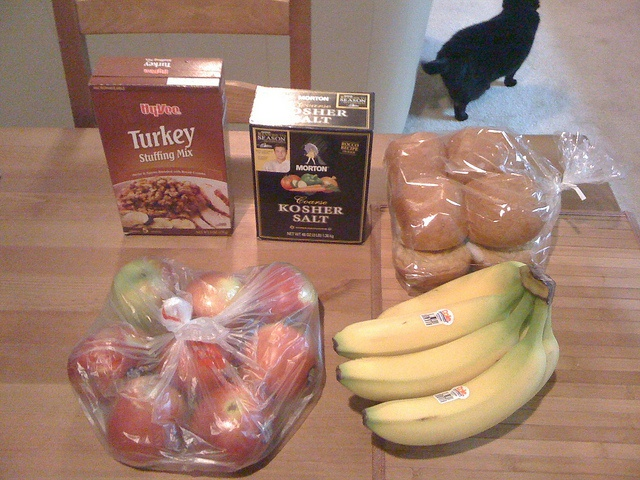Describe the objects in this image and their specific colors. I can see apple in gray, brown, lightpink, darkgray, and tan tones, banana in gray and tan tones, chair in gray and brown tones, and cat in gray, black, navy, and darkgray tones in this image. 